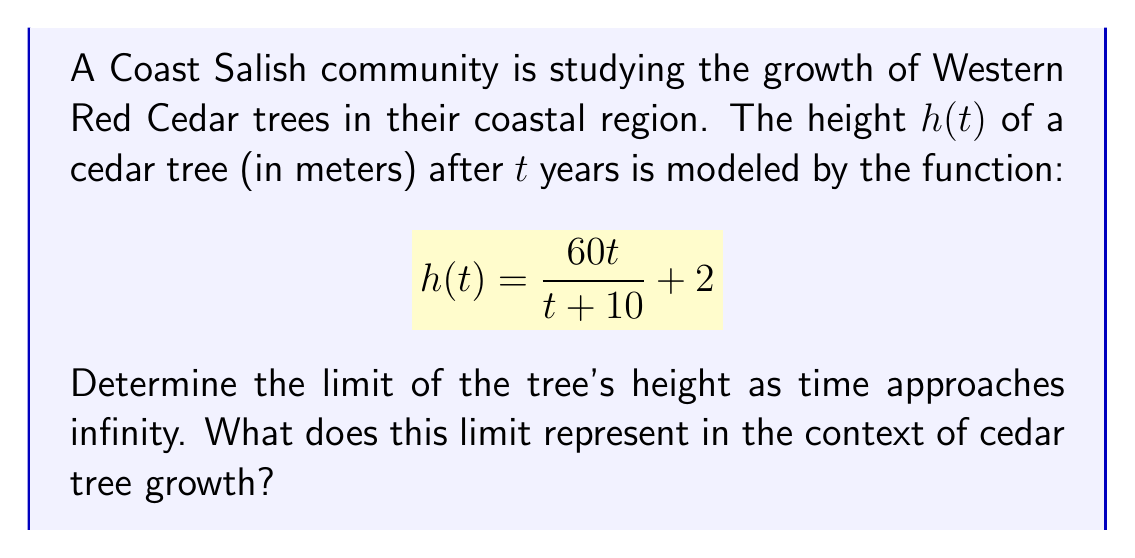Show me your answer to this math problem. To solve this problem, we'll follow these steps:

1) First, we need to evaluate $\lim_{t \to \infty} h(t)$. Let's break this down:

   $$\lim_{t \to \infty} h(t) = \lim_{t \to \infty} \left(\frac{60t}{t + 10} + 2\right)$$

2) We can separate this limit:

   $$\lim_{t \to \infty} \frac{60t}{t + 10} + \lim_{t \to \infty} 2$$

3) The limit of a constant is the constant itself, so $\lim_{t \to \infty} 2 = 2$.

4) For the first term, both numerator and denominator approach infinity as $t$ approaches infinity. We can use the following technique:

   $$\lim_{t \to \infty} \frac{60t}{t + 10} = \lim_{t \to \infty} \frac{60t/t}{(t + 10)/t} = \lim_{t \to \infty} \frac{60}{1 + 10/t}$$

5) As $t$ approaches infinity, $10/t$ approaches 0, so:

   $$\lim_{t \to \infty} \frac{60}{1 + 10/t} = \frac{60}{1 + 0} = 60$$

6) Combining the results from steps 3 and 5:

   $$\lim_{t \to \infty} h(t) = 60 + 2 = 62$$

In the context of cedar tree growth, this limit represents the maximum height that the tree can attain according to this model. It suggests that as time goes on, the cedar tree's height will approach, but never exceed, 62 meters.

This aligns with the biological concept of asymptotic growth, where organisms have a theoretical maximum size due to various limiting factors such as the ability to transport nutrients and water to the top of the tree, structural limitations, and environmental constraints.
Answer: The limit of the function as time approaches infinity is 62 meters. This represents the theoretical maximum height of the Western Red Cedar tree in this coastal region according to the given growth model. 